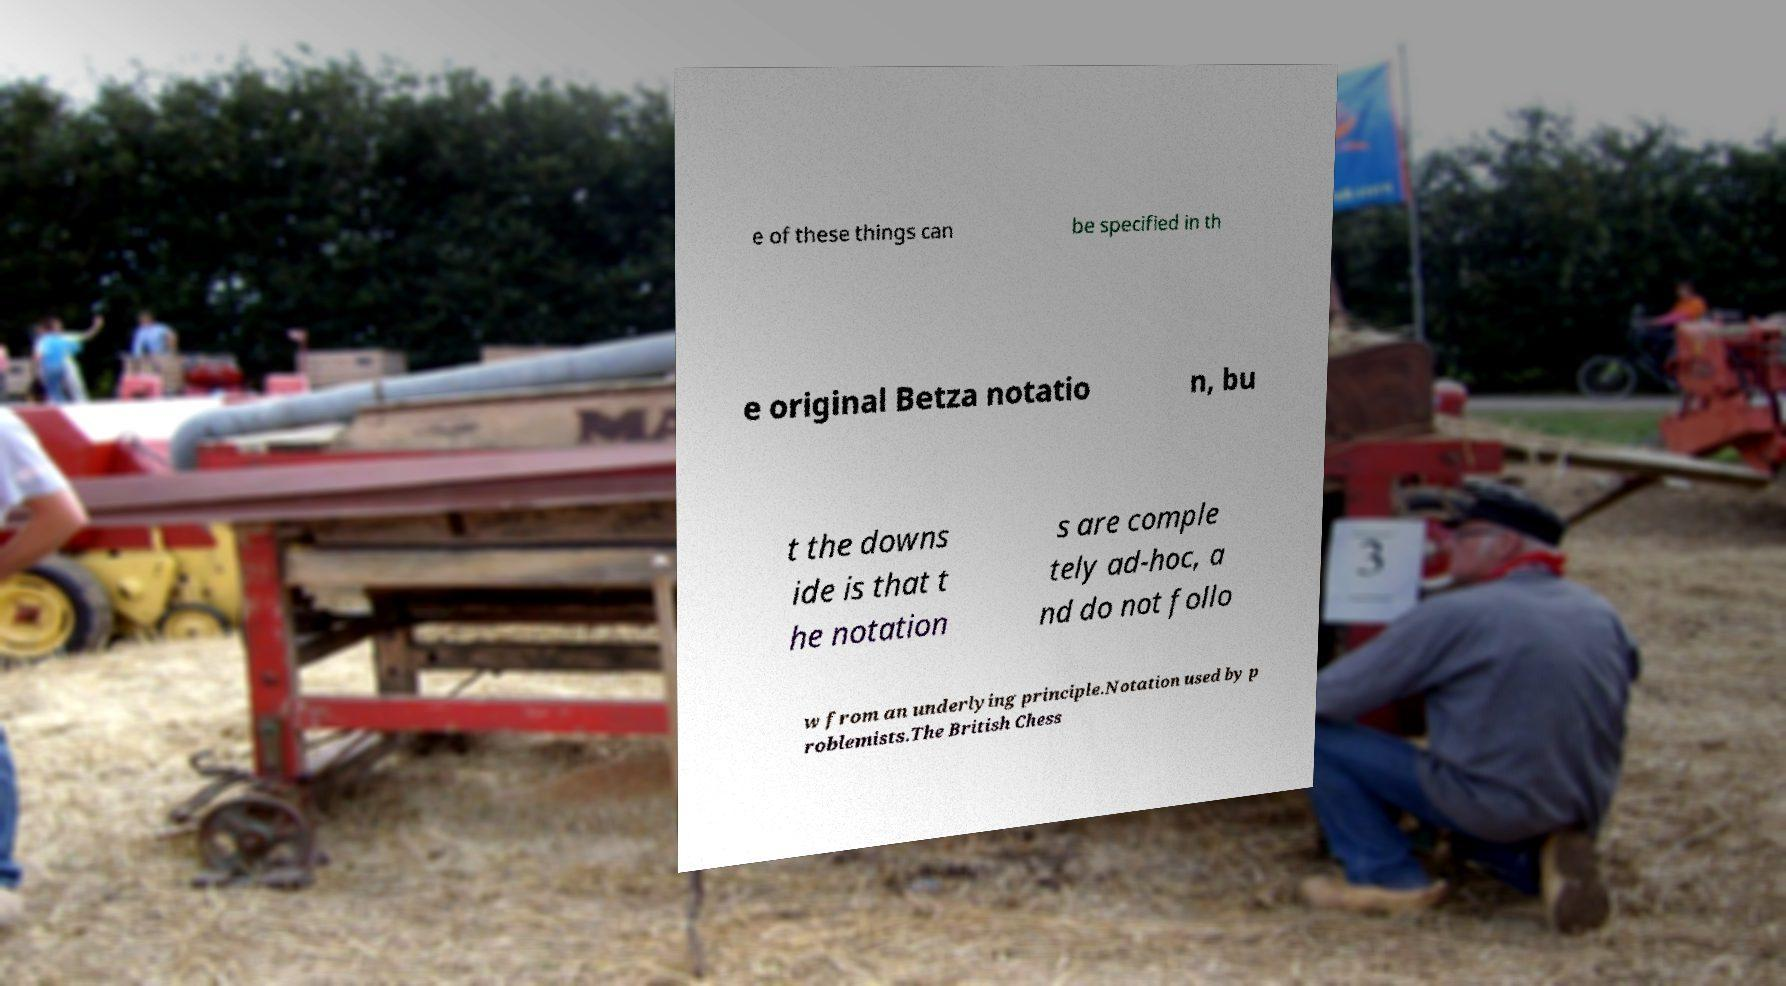What messages or text are displayed in this image? I need them in a readable, typed format. e of these things can be specified in th e original Betza notatio n, bu t the downs ide is that t he notation s are comple tely ad-hoc, a nd do not follo w from an underlying principle.Notation used by p roblemists.The British Chess 